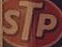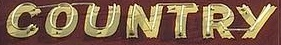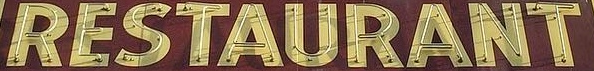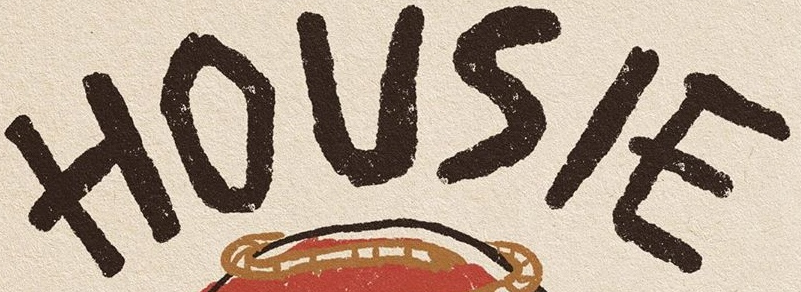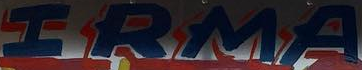Read the text content from these images in order, separated by a semicolon. STP; COUNTRY; RESTAURANT; HOUSIE; IRMA 